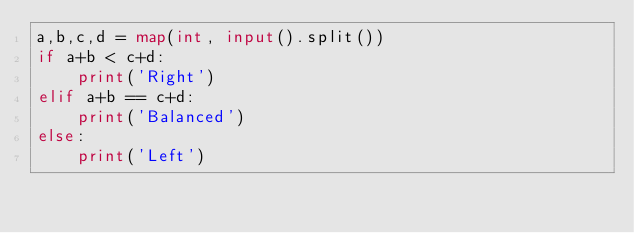<code> <loc_0><loc_0><loc_500><loc_500><_Python_>a,b,c,d = map(int, input().split())
if a+b < c+d:
    print('Right')
elif a+b == c+d:
    print('Balanced')
else:
    print('Left')</code> 